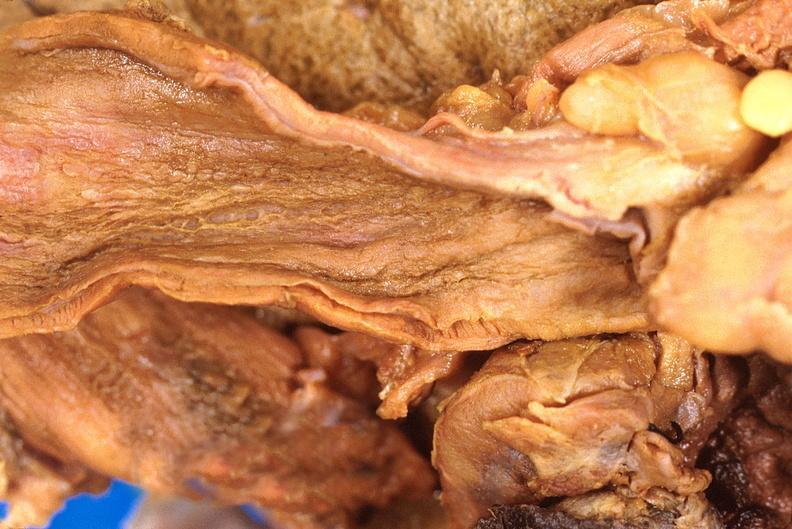what is stomach , necrotizing esophagitis and gastritis , sulfuric acid ingested?
Answer the question using a single word or phrase. As suicide attempt 